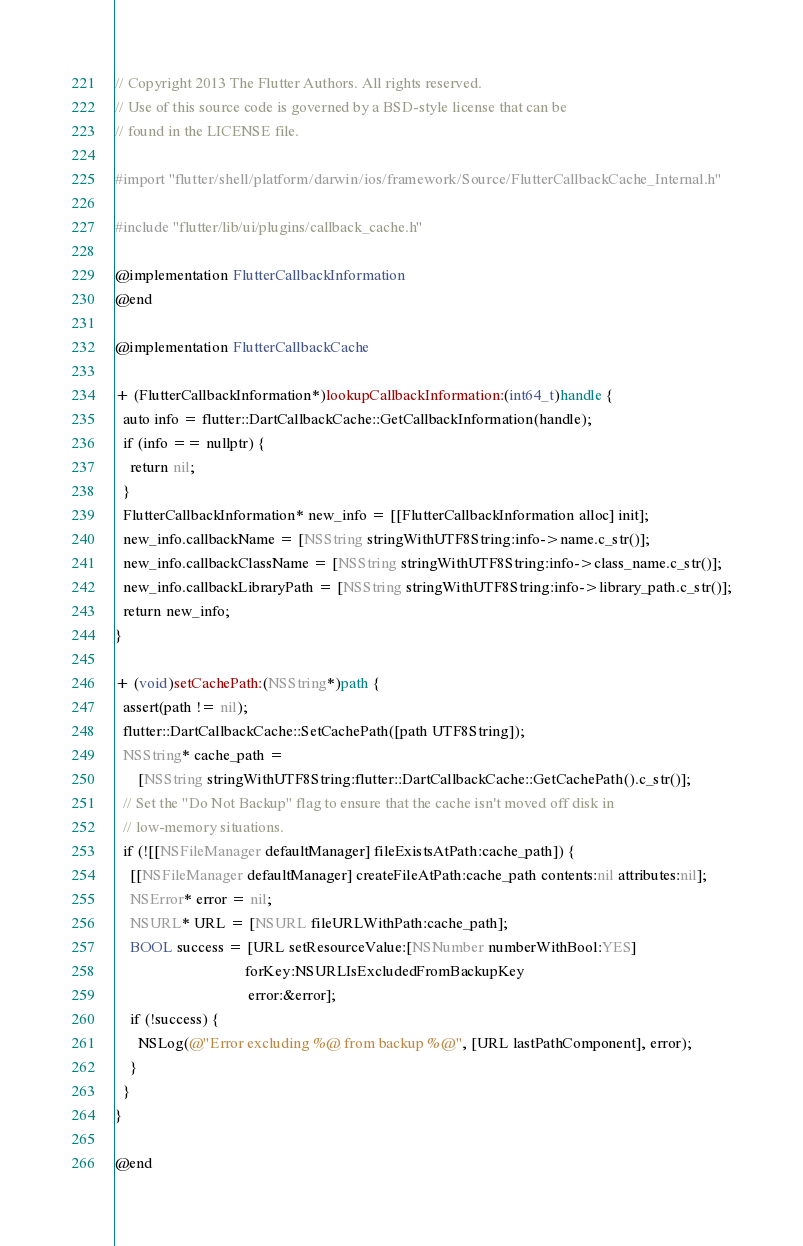<code> <loc_0><loc_0><loc_500><loc_500><_ObjectiveC_>// Copyright 2013 The Flutter Authors. All rights reserved.
// Use of this source code is governed by a BSD-style license that can be
// found in the LICENSE file.

#import "flutter/shell/platform/darwin/ios/framework/Source/FlutterCallbackCache_Internal.h"

#include "flutter/lib/ui/plugins/callback_cache.h"

@implementation FlutterCallbackInformation
@end

@implementation FlutterCallbackCache

+ (FlutterCallbackInformation*)lookupCallbackInformation:(int64_t)handle {
  auto info = flutter::DartCallbackCache::GetCallbackInformation(handle);
  if (info == nullptr) {
    return nil;
  }
  FlutterCallbackInformation* new_info = [[FlutterCallbackInformation alloc] init];
  new_info.callbackName = [NSString stringWithUTF8String:info->name.c_str()];
  new_info.callbackClassName = [NSString stringWithUTF8String:info->class_name.c_str()];
  new_info.callbackLibraryPath = [NSString stringWithUTF8String:info->library_path.c_str()];
  return new_info;
}

+ (void)setCachePath:(NSString*)path {
  assert(path != nil);
  flutter::DartCallbackCache::SetCachePath([path UTF8String]);
  NSString* cache_path =
      [NSString stringWithUTF8String:flutter::DartCallbackCache::GetCachePath().c_str()];
  // Set the "Do Not Backup" flag to ensure that the cache isn't moved off disk in
  // low-memory situations.
  if (![[NSFileManager defaultManager] fileExistsAtPath:cache_path]) {
    [[NSFileManager defaultManager] createFileAtPath:cache_path contents:nil attributes:nil];
    NSError* error = nil;
    NSURL* URL = [NSURL fileURLWithPath:cache_path];
    BOOL success = [URL setResourceValue:[NSNumber numberWithBool:YES]
                                  forKey:NSURLIsExcludedFromBackupKey
                                   error:&error];
    if (!success) {
      NSLog(@"Error excluding %@ from backup %@", [URL lastPathComponent], error);
    }
  }
}

@end
</code> 